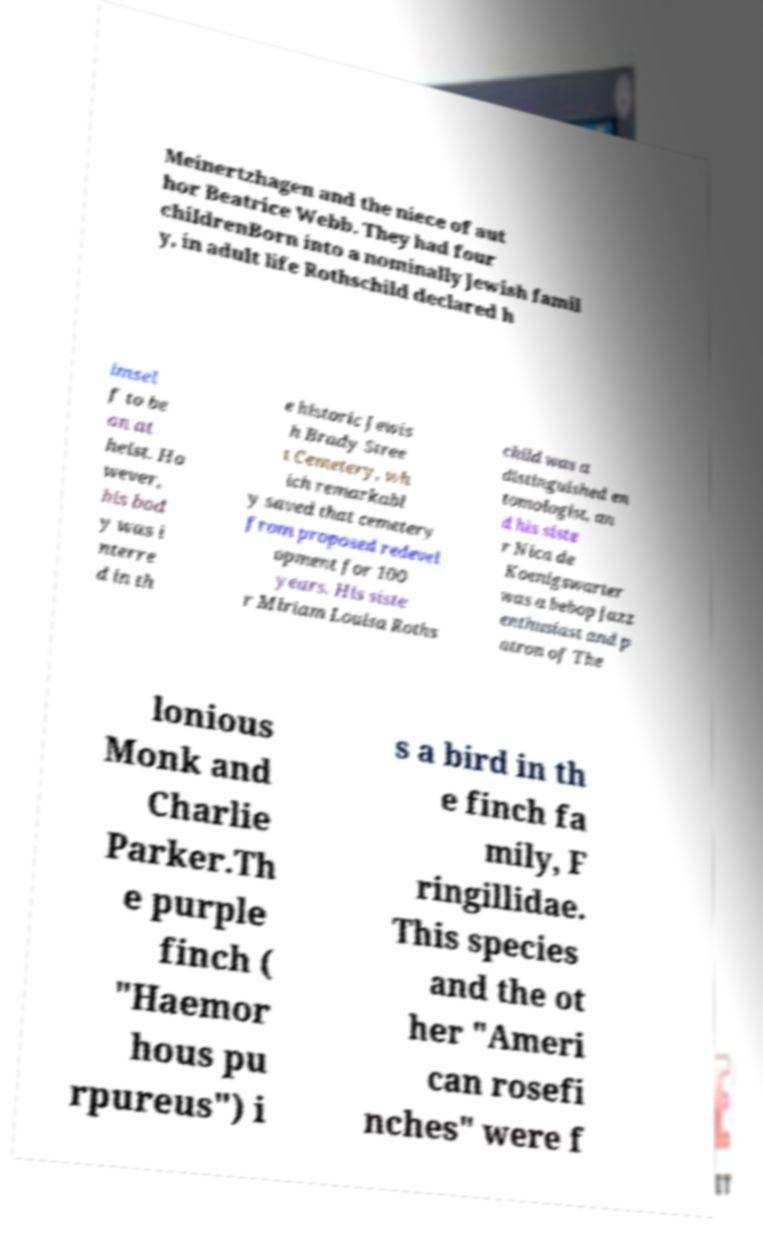Can you read and provide the text displayed in the image?This photo seems to have some interesting text. Can you extract and type it out for me? Meinertzhagen and the niece of aut hor Beatrice Webb. They had four childrenBorn into a nominally Jewish famil y, in adult life Rothschild declared h imsel f to be an at heist. Ho wever, his bod y was i nterre d in th e historic Jewis h Brady Stree t Cemetery, wh ich remarkabl y saved that cemetery from proposed redevel opment for 100 years. His siste r Miriam Louisa Roths child was a distinguished en tomologist, an d his siste r Nica de Koenigswarter was a bebop jazz enthusiast and p atron of The lonious Monk and Charlie Parker.Th e purple finch ( "Haemor hous pu rpureus") i s a bird in th e finch fa mily, F ringillidae. This species and the ot her "Ameri can rosefi nches" were f 